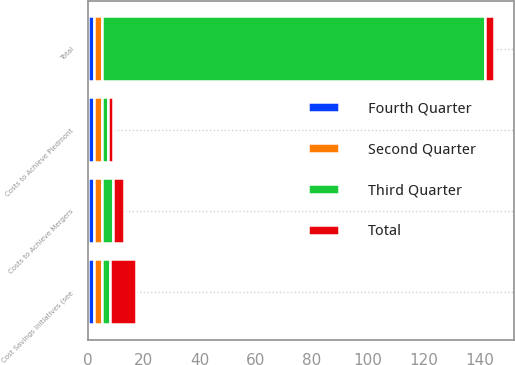Convert chart. <chart><loc_0><loc_0><loc_500><loc_500><stacked_bar_chart><ecel><fcel>Costs to Achieve Piedmont<fcel>Total<fcel>Costs to Achieve Mergers<fcel>Cost Savings Initiatives (see<nl><fcel>Fourth Quarter<fcel>2<fcel>2<fcel>2<fcel>2<nl><fcel>Second Quarter<fcel>3<fcel>3<fcel>3<fcel>3<nl><fcel>Third Quarter<fcel>2<fcel>137<fcel>4<fcel>3<nl><fcel>Total<fcel>2<fcel>3<fcel>4<fcel>9<nl></chart> 